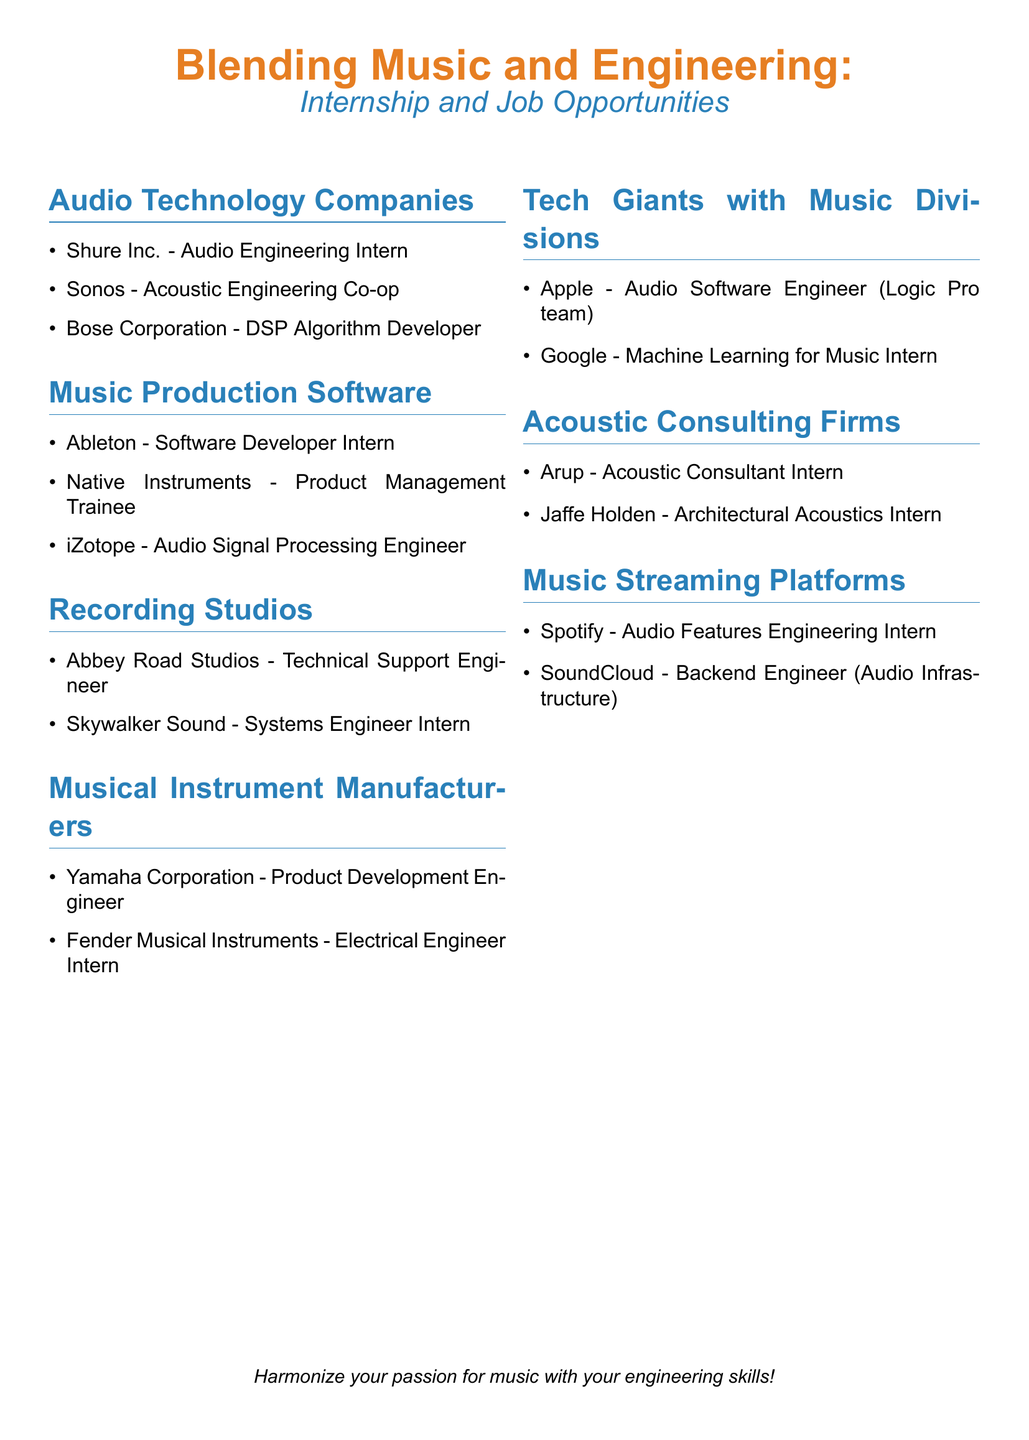What company is seeking an Audio Engineering Intern? The company listed for the Audio Engineering Intern position is Shure Inc.
Answer: Shure Inc How many internships are listed under Music Production Software? There are three internships mentioned under Music Production Software in the document.
Answer: 3 Which company offers a position for an Electrical Engineer Intern? Fender Musical Instruments is mentioned as offering an Electrical Engineer Intern position.
Answer: Fender Musical Instruments What is the role available at Abbey Road Studios? The specific role available at Abbey Road Studios is Technical Support Engineer.
Answer: Technical Support Engineer Which internship requires knowledge in Machine Learning for Music? Google offers the internship that requires knowledge in Machine Learning for Music.
Answer: Google What type of companies are listed in the second section of the document? The second section lists 'Music Production Software' companies in terms of internship opportunities.
Answer: Music Production Software How many categories of opportunities are listed in total? There are seven categories of internship and job opportunities listed in the document.
Answer: 7 What position is available with Spotify? The position available with Spotify is Audio Features Engineering Intern.
Answer: Audio Features Engineering Intern Which company has a role in Architectural Acoustics? The role in Architectural Acoustics is offered by Jaffe Holden.
Answer: Jaffe Holden 